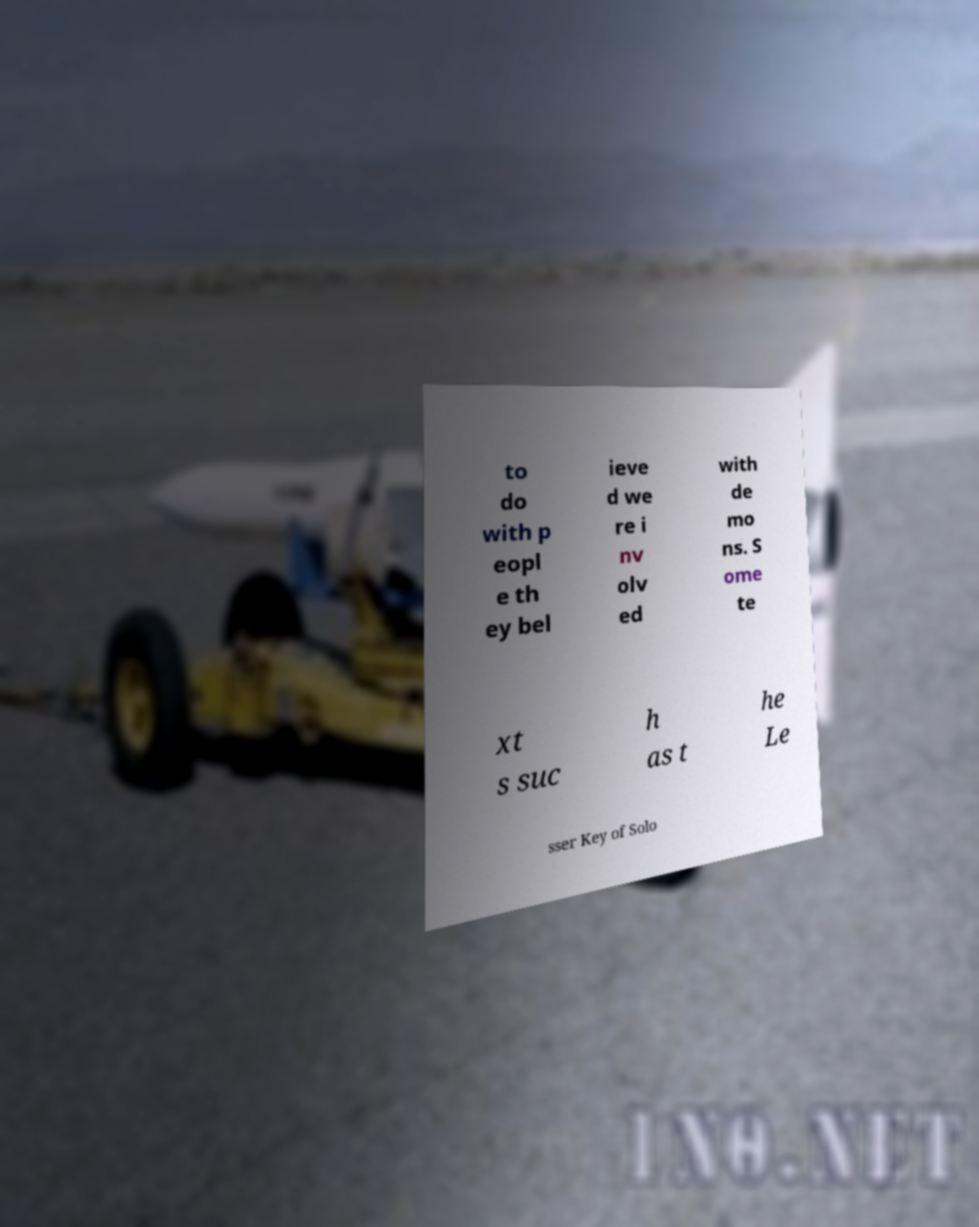Could you extract and type out the text from this image? to do with p eopl e th ey bel ieve d we re i nv olv ed with de mo ns. S ome te xt s suc h as t he Le sser Key of Solo 